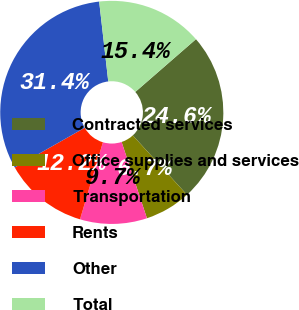Convert chart to OTSL. <chart><loc_0><loc_0><loc_500><loc_500><pie_chart><fcel>Contracted services<fcel>Office supplies and services<fcel>Transportation<fcel>Rents<fcel>Other<fcel>Total<nl><fcel>24.62%<fcel>6.67%<fcel>9.7%<fcel>12.18%<fcel>31.42%<fcel>15.41%<nl></chart> 